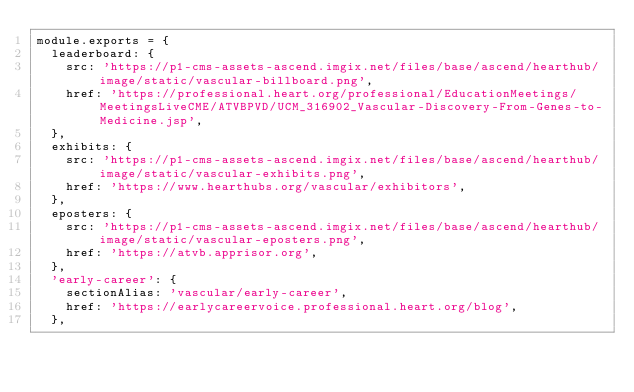<code> <loc_0><loc_0><loc_500><loc_500><_JavaScript_>module.exports = {
  leaderboard: {
    src: 'https://p1-cms-assets-ascend.imgix.net/files/base/ascend/hearthub/image/static/vascular-billboard.png',
    href: 'https://professional.heart.org/professional/EducationMeetings/MeetingsLiveCME/ATVBPVD/UCM_316902_Vascular-Discovery-From-Genes-to-Medicine.jsp',
  },
  exhibits: {
    src: 'https://p1-cms-assets-ascend.imgix.net/files/base/ascend/hearthub/image/static/vascular-exhibits.png',
    href: 'https://www.hearthubs.org/vascular/exhibitors',
  },
  eposters: {
    src: 'https://p1-cms-assets-ascend.imgix.net/files/base/ascend/hearthub/image/static/vascular-eposters.png',
    href: 'https://atvb.apprisor.org',
  },
  'early-career': {
    sectionAlias: 'vascular/early-career',
    href: 'https://earlycareervoice.professional.heart.org/blog',
  },</code> 